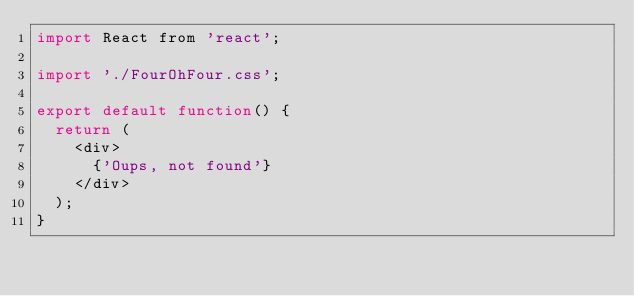Convert code to text. <code><loc_0><loc_0><loc_500><loc_500><_JavaScript_>import React from 'react';

import './FourOhFour.css';

export default function() {
  return (
    <div>
      {'Oups, not found'}
    </div>
  );
}
</code> 